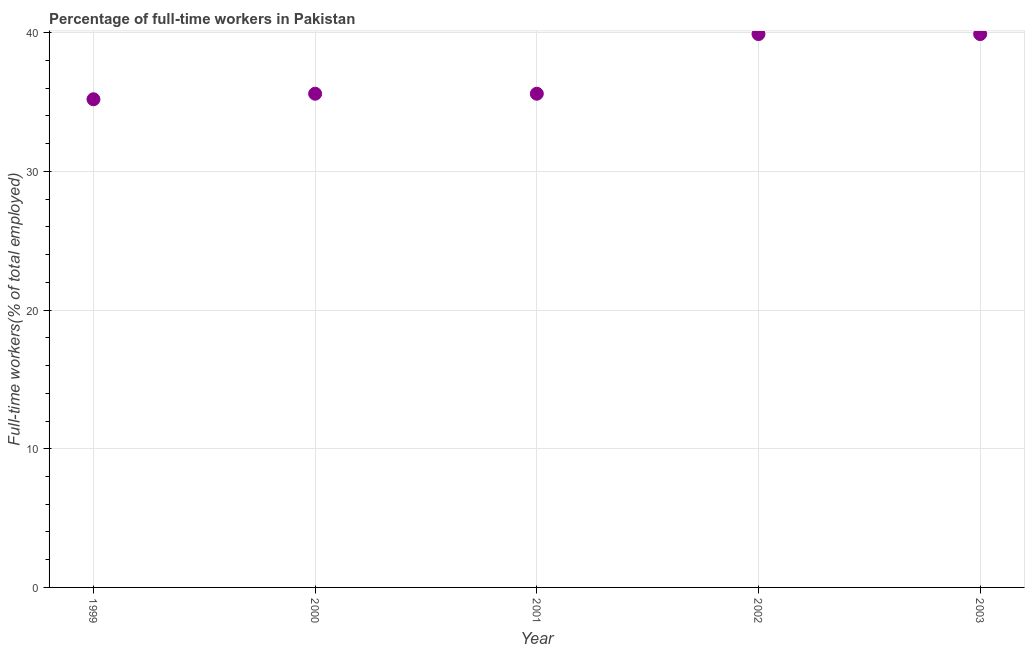What is the percentage of full-time workers in 2001?
Your answer should be compact. 35.6. Across all years, what is the maximum percentage of full-time workers?
Give a very brief answer. 39.9. Across all years, what is the minimum percentage of full-time workers?
Keep it short and to the point. 35.2. In which year was the percentage of full-time workers maximum?
Ensure brevity in your answer.  2002. In which year was the percentage of full-time workers minimum?
Your answer should be very brief. 1999. What is the sum of the percentage of full-time workers?
Your answer should be compact. 186.2. What is the difference between the percentage of full-time workers in 2000 and 2003?
Make the answer very short. -4.3. What is the average percentage of full-time workers per year?
Offer a very short reply. 37.24. What is the median percentage of full-time workers?
Provide a succinct answer. 35.6. Do a majority of the years between 2000 and 2003 (inclusive) have percentage of full-time workers greater than 12 %?
Your answer should be compact. Yes. What is the ratio of the percentage of full-time workers in 2000 to that in 2002?
Make the answer very short. 0.89. Is the difference between the percentage of full-time workers in 1999 and 2000 greater than the difference between any two years?
Provide a short and direct response. No. Is the sum of the percentage of full-time workers in 1999 and 2003 greater than the maximum percentage of full-time workers across all years?
Your answer should be very brief. Yes. What is the difference between the highest and the lowest percentage of full-time workers?
Offer a very short reply. 4.7. Does the percentage of full-time workers monotonically increase over the years?
Your response must be concise. No. Are the values on the major ticks of Y-axis written in scientific E-notation?
Ensure brevity in your answer.  No. Does the graph contain any zero values?
Your response must be concise. No. Does the graph contain grids?
Provide a short and direct response. Yes. What is the title of the graph?
Offer a terse response. Percentage of full-time workers in Pakistan. What is the label or title of the Y-axis?
Your response must be concise. Full-time workers(% of total employed). What is the Full-time workers(% of total employed) in 1999?
Keep it short and to the point. 35.2. What is the Full-time workers(% of total employed) in 2000?
Your answer should be compact. 35.6. What is the Full-time workers(% of total employed) in 2001?
Provide a short and direct response. 35.6. What is the Full-time workers(% of total employed) in 2002?
Make the answer very short. 39.9. What is the Full-time workers(% of total employed) in 2003?
Give a very brief answer. 39.9. What is the difference between the Full-time workers(% of total employed) in 1999 and 2000?
Your response must be concise. -0.4. What is the difference between the Full-time workers(% of total employed) in 1999 and 2001?
Offer a terse response. -0.4. What is the difference between the Full-time workers(% of total employed) in 1999 and 2002?
Your response must be concise. -4.7. What is the difference between the Full-time workers(% of total employed) in 1999 and 2003?
Provide a succinct answer. -4.7. What is the difference between the Full-time workers(% of total employed) in 2000 and 2001?
Provide a short and direct response. 0. What is the difference between the Full-time workers(% of total employed) in 2000 and 2002?
Offer a terse response. -4.3. What is the difference between the Full-time workers(% of total employed) in 2000 and 2003?
Provide a succinct answer. -4.3. What is the ratio of the Full-time workers(% of total employed) in 1999 to that in 2000?
Keep it short and to the point. 0.99. What is the ratio of the Full-time workers(% of total employed) in 1999 to that in 2002?
Your answer should be very brief. 0.88. What is the ratio of the Full-time workers(% of total employed) in 1999 to that in 2003?
Give a very brief answer. 0.88. What is the ratio of the Full-time workers(% of total employed) in 2000 to that in 2002?
Your answer should be very brief. 0.89. What is the ratio of the Full-time workers(% of total employed) in 2000 to that in 2003?
Your answer should be compact. 0.89. What is the ratio of the Full-time workers(% of total employed) in 2001 to that in 2002?
Your answer should be compact. 0.89. What is the ratio of the Full-time workers(% of total employed) in 2001 to that in 2003?
Offer a very short reply. 0.89. What is the ratio of the Full-time workers(% of total employed) in 2002 to that in 2003?
Ensure brevity in your answer.  1. 